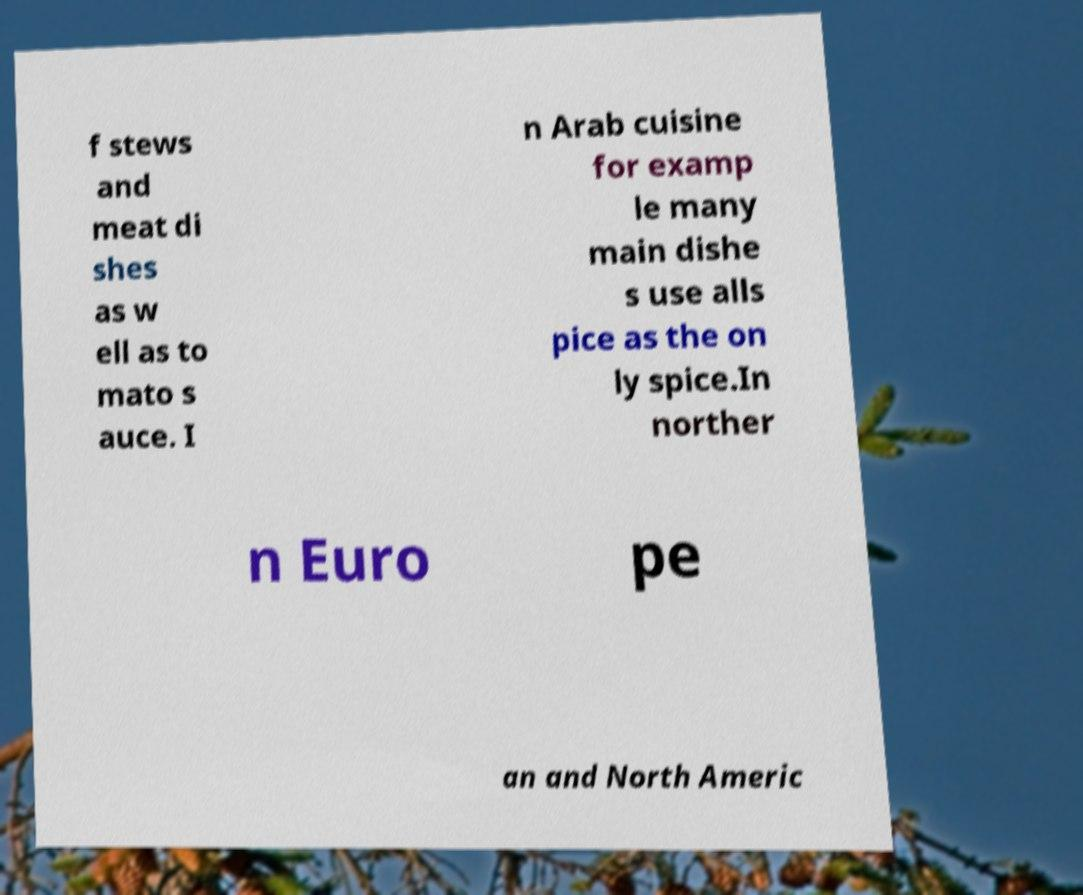Could you assist in decoding the text presented in this image and type it out clearly? f stews and meat di shes as w ell as to mato s auce. I n Arab cuisine for examp le many main dishe s use alls pice as the on ly spice.In norther n Euro pe an and North Americ 